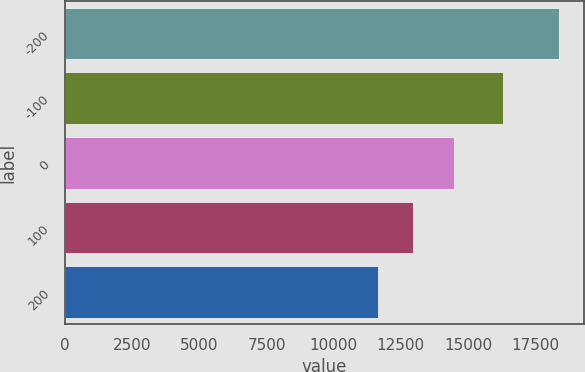Convert chart to OTSL. <chart><loc_0><loc_0><loc_500><loc_500><bar_chart><fcel>-200<fcel>-100<fcel>0<fcel>100<fcel>200<nl><fcel>18401<fcel>16287<fcel>14493<fcel>12961<fcel>11645<nl></chart> 